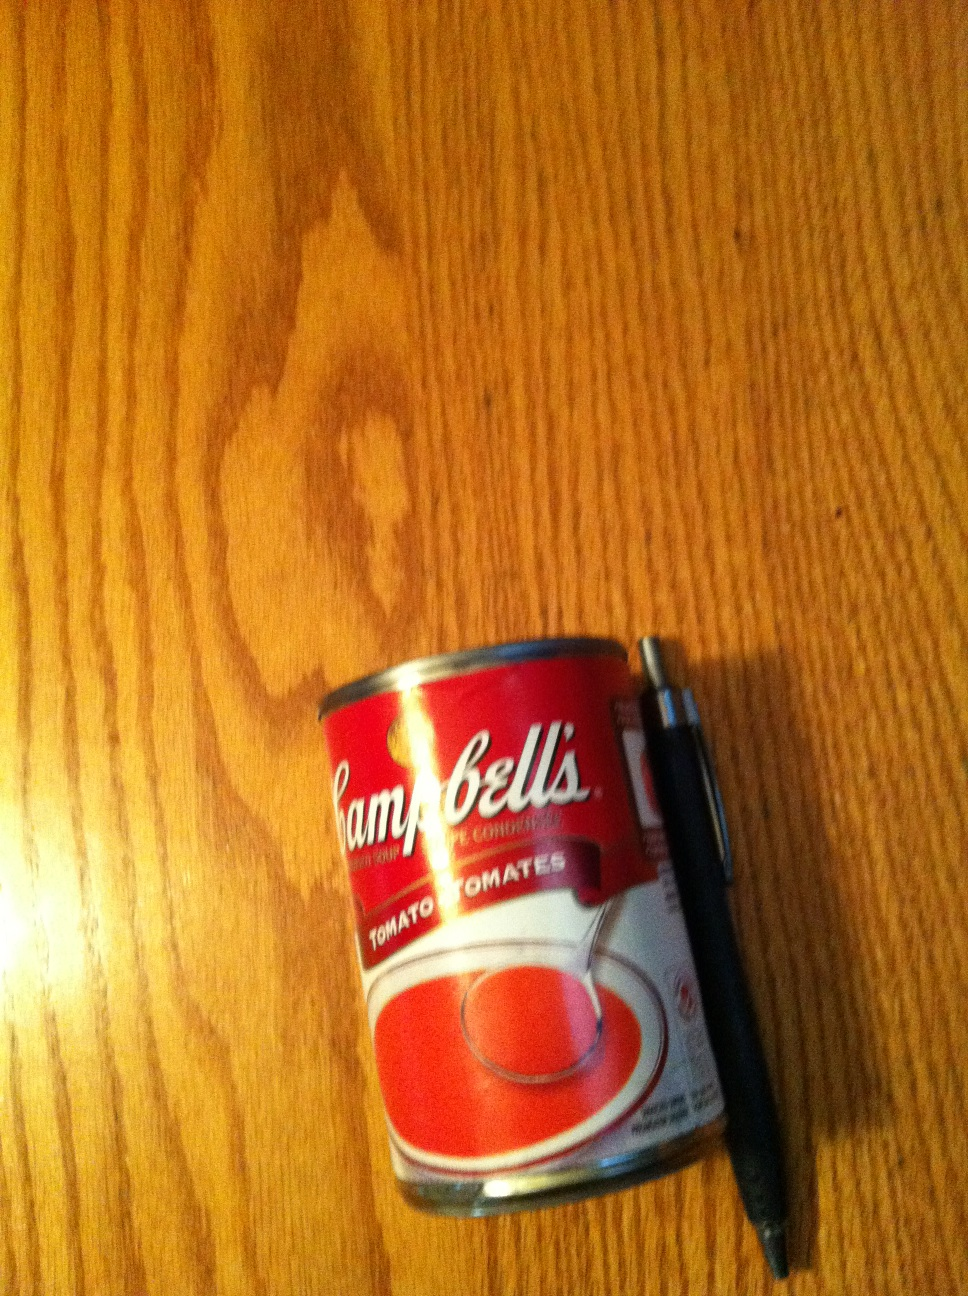Could you describe the surroundings where this photo is taken? The photo appears to be taken on a wooden surface, likely a table or countertop, with a clear wood grain texture. There's a noticeable watermark or stain on the wood, indicating use over time. 